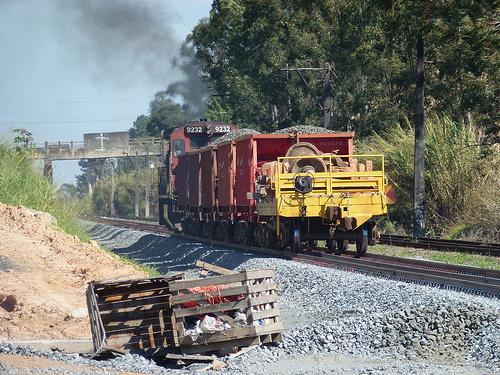Are there any numbers visible on the train? If so, what are they? Yes, the numbers 9232 are displayed twice on the top of the train. What can be seen sitting on the dirt pile? There is no grass on the dirt pile; it appears to be just dirt and rocks. Specify the location of the crate filled with garbage. The crate full of garbage is on the ground near the side of the train tracks. Describe the bridge in the image in relation to the train. There is a gray bridge behind the train, situated over the train tracks. What color is the train mentioned in the image and what is it carrying? The train is red and yellow in color, carrying gravel in its cars. List two objects that are placed on the side of the train tracks. Rocks and gravel, and two wooden boxes are placed on the side of the train tracks. Mention the type and color of vegetation near the train tracks. Tall green grass and green trees are present near the train tracks. What is the condition of the sky in the image? The sky in the image is clear and blue. Identify three elements present in the scene next to the train tracks. Wooden crates, pile of dirt, and green trees can be seen next to the train tracks. What kind of smoke is coming from the train, and what color is it? Dark gray smoke is coming from the train. 